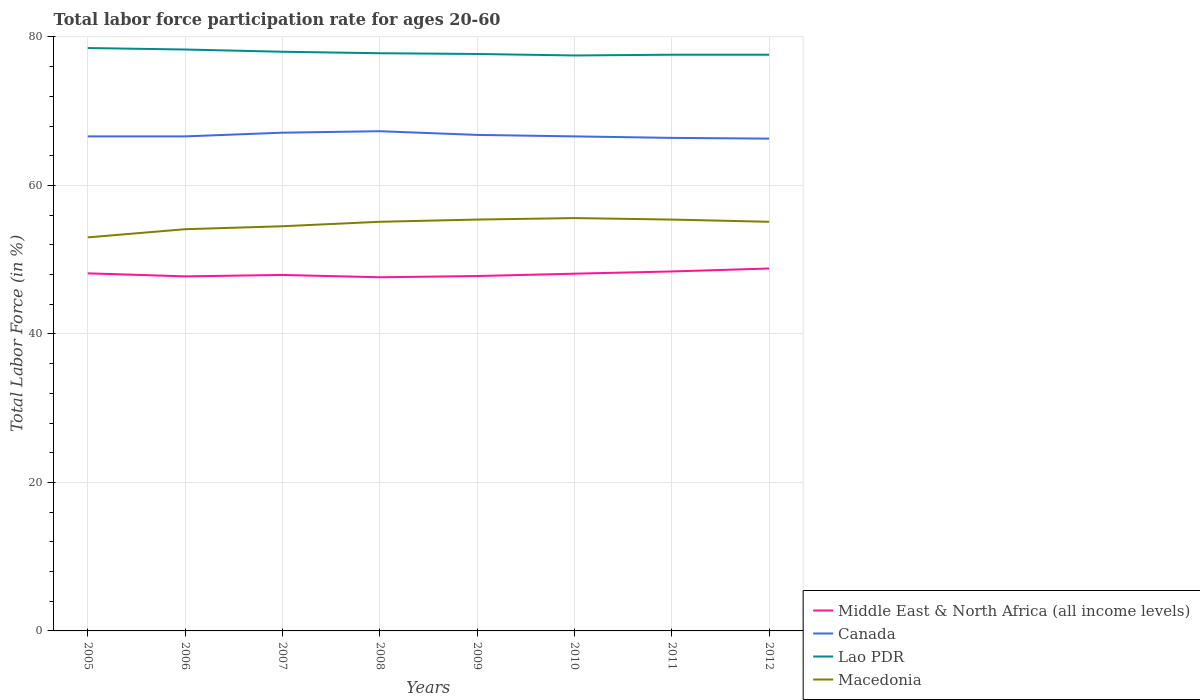Across all years, what is the maximum labor force participation rate in Middle East & North Africa (all income levels)?
Provide a short and direct response. 47.63. In which year was the labor force participation rate in Macedonia maximum?
Offer a terse response. 2005. What is the total labor force participation rate in Macedonia in the graph?
Offer a very short reply. -0.3. What is the difference between the highest and the second highest labor force participation rate in Middle East & North Africa (all income levels)?
Provide a short and direct response. 1.18. What is the difference between the highest and the lowest labor force participation rate in Macedonia?
Provide a short and direct response. 5. Where does the legend appear in the graph?
Keep it short and to the point. Bottom right. How many legend labels are there?
Your answer should be compact. 4. What is the title of the graph?
Your answer should be very brief. Total labor force participation rate for ages 20-60. What is the label or title of the X-axis?
Provide a short and direct response. Years. What is the label or title of the Y-axis?
Provide a succinct answer. Total Labor Force (in %). What is the Total Labor Force (in %) in Middle East & North Africa (all income levels) in 2005?
Keep it short and to the point. 48.16. What is the Total Labor Force (in %) in Canada in 2005?
Offer a terse response. 66.6. What is the Total Labor Force (in %) in Lao PDR in 2005?
Keep it short and to the point. 78.5. What is the Total Labor Force (in %) of Middle East & North Africa (all income levels) in 2006?
Offer a very short reply. 47.75. What is the Total Labor Force (in %) of Canada in 2006?
Provide a short and direct response. 66.6. What is the Total Labor Force (in %) of Lao PDR in 2006?
Provide a short and direct response. 78.3. What is the Total Labor Force (in %) of Macedonia in 2006?
Make the answer very short. 54.1. What is the Total Labor Force (in %) of Middle East & North Africa (all income levels) in 2007?
Provide a succinct answer. 47.94. What is the Total Labor Force (in %) in Canada in 2007?
Make the answer very short. 67.1. What is the Total Labor Force (in %) of Lao PDR in 2007?
Make the answer very short. 78. What is the Total Labor Force (in %) in Macedonia in 2007?
Give a very brief answer. 54.5. What is the Total Labor Force (in %) in Middle East & North Africa (all income levels) in 2008?
Provide a short and direct response. 47.63. What is the Total Labor Force (in %) of Canada in 2008?
Provide a short and direct response. 67.3. What is the Total Labor Force (in %) of Lao PDR in 2008?
Your answer should be very brief. 77.8. What is the Total Labor Force (in %) of Macedonia in 2008?
Give a very brief answer. 55.1. What is the Total Labor Force (in %) in Middle East & North Africa (all income levels) in 2009?
Your response must be concise. 47.79. What is the Total Labor Force (in %) of Canada in 2009?
Offer a very short reply. 66.8. What is the Total Labor Force (in %) in Lao PDR in 2009?
Ensure brevity in your answer.  77.7. What is the Total Labor Force (in %) of Macedonia in 2009?
Your answer should be very brief. 55.4. What is the Total Labor Force (in %) of Middle East & North Africa (all income levels) in 2010?
Offer a very short reply. 48.11. What is the Total Labor Force (in %) of Canada in 2010?
Give a very brief answer. 66.6. What is the Total Labor Force (in %) of Lao PDR in 2010?
Offer a terse response. 77.5. What is the Total Labor Force (in %) in Macedonia in 2010?
Your answer should be very brief. 55.6. What is the Total Labor Force (in %) in Middle East & North Africa (all income levels) in 2011?
Give a very brief answer. 48.41. What is the Total Labor Force (in %) in Canada in 2011?
Ensure brevity in your answer.  66.4. What is the Total Labor Force (in %) of Lao PDR in 2011?
Ensure brevity in your answer.  77.6. What is the Total Labor Force (in %) of Macedonia in 2011?
Offer a very short reply. 55.4. What is the Total Labor Force (in %) in Middle East & North Africa (all income levels) in 2012?
Give a very brief answer. 48.81. What is the Total Labor Force (in %) in Canada in 2012?
Your response must be concise. 66.3. What is the Total Labor Force (in %) in Lao PDR in 2012?
Provide a short and direct response. 77.6. What is the Total Labor Force (in %) in Macedonia in 2012?
Offer a very short reply. 55.1. Across all years, what is the maximum Total Labor Force (in %) of Middle East & North Africa (all income levels)?
Provide a succinct answer. 48.81. Across all years, what is the maximum Total Labor Force (in %) in Canada?
Offer a terse response. 67.3. Across all years, what is the maximum Total Labor Force (in %) in Lao PDR?
Make the answer very short. 78.5. Across all years, what is the maximum Total Labor Force (in %) in Macedonia?
Offer a terse response. 55.6. Across all years, what is the minimum Total Labor Force (in %) in Middle East & North Africa (all income levels)?
Ensure brevity in your answer.  47.63. Across all years, what is the minimum Total Labor Force (in %) in Canada?
Your answer should be compact. 66.3. Across all years, what is the minimum Total Labor Force (in %) in Lao PDR?
Your response must be concise. 77.5. Across all years, what is the minimum Total Labor Force (in %) in Macedonia?
Offer a terse response. 53. What is the total Total Labor Force (in %) in Middle East & North Africa (all income levels) in the graph?
Your response must be concise. 384.6. What is the total Total Labor Force (in %) of Canada in the graph?
Give a very brief answer. 533.7. What is the total Total Labor Force (in %) of Lao PDR in the graph?
Offer a terse response. 623. What is the total Total Labor Force (in %) of Macedonia in the graph?
Your answer should be very brief. 438.2. What is the difference between the Total Labor Force (in %) of Middle East & North Africa (all income levels) in 2005 and that in 2006?
Your answer should be compact. 0.41. What is the difference between the Total Labor Force (in %) of Middle East & North Africa (all income levels) in 2005 and that in 2007?
Make the answer very short. 0.22. What is the difference between the Total Labor Force (in %) of Middle East & North Africa (all income levels) in 2005 and that in 2008?
Your answer should be compact. 0.53. What is the difference between the Total Labor Force (in %) in Canada in 2005 and that in 2008?
Provide a short and direct response. -0.7. What is the difference between the Total Labor Force (in %) of Macedonia in 2005 and that in 2008?
Offer a very short reply. -2.1. What is the difference between the Total Labor Force (in %) in Middle East & North Africa (all income levels) in 2005 and that in 2009?
Your response must be concise. 0.36. What is the difference between the Total Labor Force (in %) in Macedonia in 2005 and that in 2009?
Offer a terse response. -2.4. What is the difference between the Total Labor Force (in %) in Middle East & North Africa (all income levels) in 2005 and that in 2010?
Your answer should be compact. 0.05. What is the difference between the Total Labor Force (in %) of Canada in 2005 and that in 2010?
Your answer should be very brief. 0. What is the difference between the Total Labor Force (in %) in Macedonia in 2005 and that in 2010?
Offer a terse response. -2.6. What is the difference between the Total Labor Force (in %) of Middle East & North Africa (all income levels) in 2005 and that in 2011?
Keep it short and to the point. -0.25. What is the difference between the Total Labor Force (in %) of Canada in 2005 and that in 2011?
Provide a short and direct response. 0.2. What is the difference between the Total Labor Force (in %) in Macedonia in 2005 and that in 2011?
Your answer should be compact. -2.4. What is the difference between the Total Labor Force (in %) of Middle East & North Africa (all income levels) in 2005 and that in 2012?
Make the answer very short. -0.65. What is the difference between the Total Labor Force (in %) in Canada in 2005 and that in 2012?
Make the answer very short. 0.3. What is the difference between the Total Labor Force (in %) in Macedonia in 2005 and that in 2012?
Provide a succinct answer. -2.1. What is the difference between the Total Labor Force (in %) in Middle East & North Africa (all income levels) in 2006 and that in 2007?
Make the answer very short. -0.19. What is the difference between the Total Labor Force (in %) in Lao PDR in 2006 and that in 2007?
Your response must be concise. 0.3. What is the difference between the Total Labor Force (in %) in Macedonia in 2006 and that in 2007?
Provide a short and direct response. -0.4. What is the difference between the Total Labor Force (in %) of Middle East & North Africa (all income levels) in 2006 and that in 2008?
Ensure brevity in your answer.  0.12. What is the difference between the Total Labor Force (in %) of Middle East & North Africa (all income levels) in 2006 and that in 2009?
Keep it short and to the point. -0.04. What is the difference between the Total Labor Force (in %) in Middle East & North Africa (all income levels) in 2006 and that in 2010?
Your response must be concise. -0.36. What is the difference between the Total Labor Force (in %) in Middle East & North Africa (all income levels) in 2006 and that in 2011?
Offer a terse response. -0.66. What is the difference between the Total Labor Force (in %) in Middle East & North Africa (all income levels) in 2006 and that in 2012?
Offer a very short reply. -1.06. What is the difference between the Total Labor Force (in %) of Middle East & North Africa (all income levels) in 2007 and that in 2008?
Ensure brevity in your answer.  0.31. What is the difference between the Total Labor Force (in %) of Lao PDR in 2007 and that in 2008?
Give a very brief answer. 0.2. What is the difference between the Total Labor Force (in %) of Middle East & North Africa (all income levels) in 2007 and that in 2009?
Your answer should be very brief. 0.15. What is the difference between the Total Labor Force (in %) in Canada in 2007 and that in 2009?
Your answer should be compact. 0.3. What is the difference between the Total Labor Force (in %) of Lao PDR in 2007 and that in 2009?
Give a very brief answer. 0.3. What is the difference between the Total Labor Force (in %) of Macedonia in 2007 and that in 2009?
Your response must be concise. -0.9. What is the difference between the Total Labor Force (in %) of Middle East & North Africa (all income levels) in 2007 and that in 2010?
Your response must be concise. -0.17. What is the difference between the Total Labor Force (in %) of Lao PDR in 2007 and that in 2010?
Provide a succinct answer. 0.5. What is the difference between the Total Labor Force (in %) of Middle East & North Africa (all income levels) in 2007 and that in 2011?
Make the answer very short. -0.47. What is the difference between the Total Labor Force (in %) of Canada in 2007 and that in 2011?
Give a very brief answer. 0.7. What is the difference between the Total Labor Force (in %) of Lao PDR in 2007 and that in 2011?
Your answer should be compact. 0.4. What is the difference between the Total Labor Force (in %) of Middle East & North Africa (all income levels) in 2007 and that in 2012?
Provide a succinct answer. -0.87. What is the difference between the Total Labor Force (in %) of Macedonia in 2007 and that in 2012?
Offer a very short reply. -0.6. What is the difference between the Total Labor Force (in %) in Middle East & North Africa (all income levels) in 2008 and that in 2009?
Offer a terse response. -0.16. What is the difference between the Total Labor Force (in %) in Lao PDR in 2008 and that in 2009?
Your answer should be very brief. 0.1. What is the difference between the Total Labor Force (in %) of Middle East & North Africa (all income levels) in 2008 and that in 2010?
Offer a very short reply. -0.48. What is the difference between the Total Labor Force (in %) of Canada in 2008 and that in 2010?
Provide a succinct answer. 0.7. What is the difference between the Total Labor Force (in %) of Macedonia in 2008 and that in 2010?
Your response must be concise. -0.5. What is the difference between the Total Labor Force (in %) of Middle East & North Africa (all income levels) in 2008 and that in 2011?
Offer a terse response. -0.78. What is the difference between the Total Labor Force (in %) of Canada in 2008 and that in 2011?
Offer a very short reply. 0.9. What is the difference between the Total Labor Force (in %) of Middle East & North Africa (all income levels) in 2008 and that in 2012?
Ensure brevity in your answer.  -1.18. What is the difference between the Total Labor Force (in %) of Canada in 2008 and that in 2012?
Make the answer very short. 1. What is the difference between the Total Labor Force (in %) in Middle East & North Africa (all income levels) in 2009 and that in 2010?
Your response must be concise. -0.32. What is the difference between the Total Labor Force (in %) in Canada in 2009 and that in 2010?
Your answer should be compact. 0.2. What is the difference between the Total Labor Force (in %) in Lao PDR in 2009 and that in 2010?
Make the answer very short. 0.2. What is the difference between the Total Labor Force (in %) in Macedonia in 2009 and that in 2010?
Give a very brief answer. -0.2. What is the difference between the Total Labor Force (in %) in Middle East & North Africa (all income levels) in 2009 and that in 2011?
Make the answer very short. -0.62. What is the difference between the Total Labor Force (in %) of Lao PDR in 2009 and that in 2011?
Your answer should be compact. 0.1. What is the difference between the Total Labor Force (in %) in Middle East & North Africa (all income levels) in 2009 and that in 2012?
Keep it short and to the point. -1.02. What is the difference between the Total Labor Force (in %) in Canada in 2009 and that in 2012?
Make the answer very short. 0.5. What is the difference between the Total Labor Force (in %) of Lao PDR in 2009 and that in 2012?
Your answer should be compact. 0.1. What is the difference between the Total Labor Force (in %) in Macedonia in 2009 and that in 2012?
Give a very brief answer. 0.3. What is the difference between the Total Labor Force (in %) in Middle East & North Africa (all income levels) in 2010 and that in 2011?
Provide a succinct answer. -0.3. What is the difference between the Total Labor Force (in %) of Canada in 2010 and that in 2011?
Your response must be concise. 0.2. What is the difference between the Total Labor Force (in %) in Middle East & North Africa (all income levels) in 2010 and that in 2012?
Your answer should be very brief. -0.7. What is the difference between the Total Labor Force (in %) in Lao PDR in 2010 and that in 2012?
Provide a succinct answer. -0.1. What is the difference between the Total Labor Force (in %) of Middle East & North Africa (all income levels) in 2011 and that in 2012?
Your response must be concise. -0.4. What is the difference between the Total Labor Force (in %) in Macedonia in 2011 and that in 2012?
Your response must be concise. 0.3. What is the difference between the Total Labor Force (in %) in Middle East & North Africa (all income levels) in 2005 and the Total Labor Force (in %) in Canada in 2006?
Your response must be concise. -18.44. What is the difference between the Total Labor Force (in %) of Middle East & North Africa (all income levels) in 2005 and the Total Labor Force (in %) of Lao PDR in 2006?
Provide a short and direct response. -30.14. What is the difference between the Total Labor Force (in %) in Middle East & North Africa (all income levels) in 2005 and the Total Labor Force (in %) in Macedonia in 2006?
Make the answer very short. -5.94. What is the difference between the Total Labor Force (in %) in Canada in 2005 and the Total Labor Force (in %) in Lao PDR in 2006?
Make the answer very short. -11.7. What is the difference between the Total Labor Force (in %) of Lao PDR in 2005 and the Total Labor Force (in %) of Macedonia in 2006?
Provide a succinct answer. 24.4. What is the difference between the Total Labor Force (in %) in Middle East & North Africa (all income levels) in 2005 and the Total Labor Force (in %) in Canada in 2007?
Make the answer very short. -18.94. What is the difference between the Total Labor Force (in %) in Middle East & North Africa (all income levels) in 2005 and the Total Labor Force (in %) in Lao PDR in 2007?
Offer a very short reply. -29.84. What is the difference between the Total Labor Force (in %) in Middle East & North Africa (all income levels) in 2005 and the Total Labor Force (in %) in Macedonia in 2007?
Provide a short and direct response. -6.34. What is the difference between the Total Labor Force (in %) of Canada in 2005 and the Total Labor Force (in %) of Lao PDR in 2007?
Keep it short and to the point. -11.4. What is the difference between the Total Labor Force (in %) of Lao PDR in 2005 and the Total Labor Force (in %) of Macedonia in 2007?
Provide a succinct answer. 24. What is the difference between the Total Labor Force (in %) in Middle East & North Africa (all income levels) in 2005 and the Total Labor Force (in %) in Canada in 2008?
Your response must be concise. -19.14. What is the difference between the Total Labor Force (in %) of Middle East & North Africa (all income levels) in 2005 and the Total Labor Force (in %) of Lao PDR in 2008?
Your answer should be very brief. -29.64. What is the difference between the Total Labor Force (in %) in Middle East & North Africa (all income levels) in 2005 and the Total Labor Force (in %) in Macedonia in 2008?
Ensure brevity in your answer.  -6.94. What is the difference between the Total Labor Force (in %) of Lao PDR in 2005 and the Total Labor Force (in %) of Macedonia in 2008?
Keep it short and to the point. 23.4. What is the difference between the Total Labor Force (in %) of Middle East & North Africa (all income levels) in 2005 and the Total Labor Force (in %) of Canada in 2009?
Give a very brief answer. -18.64. What is the difference between the Total Labor Force (in %) of Middle East & North Africa (all income levels) in 2005 and the Total Labor Force (in %) of Lao PDR in 2009?
Provide a succinct answer. -29.54. What is the difference between the Total Labor Force (in %) of Middle East & North Africa (all income levels) in 2005 and the Total Labor Force (in %) of Macedonia in 2009?
Offer a very short reply. -7.24. What is the difference between the Total Labor Force (in %) in Canada in 2005 and the Total Labor Force (in %) in Lao PDR in 2009?
Your response must be concise. -11.1. What is the difference between the Total Labor Force (in %) in Canada in 2005 and the Total Labor Force (in %) in Macedonia in 2009?
Your answer should be compact. 11.2. What is the difference between the Total Labor Force (in %) of Lao PDR in 2005 and the Total Labor Force (in %) of Macedonia in 2009?
Your answer should be very brief. 23.1. What is the difference between the Total Labor Force (in %) of Middle East & North Africa (all income levels) in 2005 and the Total Labor Force (in %) of Canada in 2010?
Make the answer very short. -18.44. What is the difference between the Total Labor Force (in %) in Middle East & North Africa (all income levels) in 2005 and the Total Labor Force (in %) in Lao PDR in 2010?
Provide a short and direct response. -29.34. What is the difference between the Total Labor Force (in %) in Middle East & North Africa (all income levels) in 2005 and the Total Labor Force (in %) in Macedonia in 2010?
Ensure brevity in your answer.  -7.44. What is the difference between the Total Labor Force (in %) in Lao PDR in 2005 and the Total Labor Force (in %) in Macedonia in 2010?
Give a very brief answer. 22.9. What is the difference between the Total Labor Force (in %) in Middle East & North Africa (all income levels) in 2005 and the Total Labor Force (in %) in Canada in 2011?
Keep it short and to the point. -18.24. What is the difference between the Total Labor Force (in %) of Middle East & North Africa (all income levels) in 2005 and the Total Labor Force (in %) of Lao PDR in 2011?
Give a very brief answer. -29.44. What is the difference between the Total Labor Force (in %) in Middle East & North Africa (all income levels) in 2005 and the Total Labor Force (in %) in Macedonia in 2011?
Offer a very short reply. -7.24. What is the difference between the Total Labor Force (in %) of Canada in 2005 and the Total Labor Force (in %) of Lao PDR in 2011?
Provide a short and direct response. -11. What is the difference between the Total Labor Force (in %) in Lao PDR in 2005 and the Total Labor Force (in %) in Macedonia in 2011?
Keep it short and to the point. 23.1. What is the difference between the Total Labor Force (in %) of Middle East & North Africa (all income levels) in 2005 and the Total Labor Force (in %) of Canada in 2012?
Offer a terse response. -18.14. What is the difference between the Total Labor Force (in %) of Middle East & North Africa (all income levels) in 2005 and the Total Labor Force (in %) of Lao PDR in 2012?
Offer a very short reply. -29.44. What is the difference between the Total Labor Force (in %) of Middle East & North Africa (all income levels) in 2005 and the Total Labor Force (in %) of Macedonia in 2012?
Provide a succinct answer. -6.94. What is the difference between the Total Labor Force (in %) in Canada in 2005 and the Total Labor Force (in %) in Lao PDR in 2012?
Offer a very short reply. -11. What is the difference between the Total Labor Force (in %) in Lao PDR in 2005 and the Total Labor Force (in %) in Macedonia in 2012?
Your response must be concise. 23.4. What is the difference between the Total Labor Force (in %) of Middle East & North Africa (all income levels) in 2006 and the Total Labor Force (in %) of Canada in 2007?
Your response must be concise. -19.35. What is the difference between the Total Labor Force (in %) in Middle East & North Africa (all income levels) in 2006 and the Total Labor Force (in %) in Lao PDR in 2007?
Offer a very short reply. -30.25. What is the difference between the Total Labor Force (in %) of Middle East & North Africa (all income levels) in 2006 and the Total Labor Force (in %) of Macedonia in 2007?
Your answer should be compact. -6.75. What is the difference between the Total Labor Force (in %) of Canada in 2006 and the Total Labor Force (in %) of Lao PDR in 2007?
Make the answer very short. -11.4. What is the difference between the Total Labor Force (in %) of Lao PDR in 2006 and the Total Labor Force (in %) of Macedonia in 2007?
Give a very brief answer. 23.8. What is the difference between the Total Labor Force (in %) in Middle East & North Africa (all income levels) in 2006 and the Total Labor Force (in %) in Canada in 2008?
Give a very brief answer. -19.55. What is the difference between the Total Labor Force (in %) in Middle East & North Africa (all income levels) in 2006 and the Total Labor Force (in %) in Lao PDR in 2008?
Offer a very short reply. -30.05. What is the difference between the Total Labor Force (in %) in Middle East & North Africa (all income levels) in 2006 and the Total Labor Force (in %) in Macedonia in 2008?
Ensure brevity in your answer.  -7.35. What is the difference between the Total Labor Force (in %) in Canada in 2006 and the Total Labor Force (in %) in Lao PDR in 2008?
Provide a succinct answer. -11.2. What is the difference between the Total Labor Force (in %) of Canada in 2006 and the Total Labor Force (in %) of Macedonia in 2008?
Your answer should be very brief. 11.5. What is the difference between the Total Labor Force (in %) of Lao PDR in 2006 and the Total Labor Force (in %) of Macedonia in 2008?
Provide a succinct answer. 23.2. What is the difference between the Total Labor Force (in %) in Middle East & North Africa (all income levels) in 2006 and the Total Labor Force (in %) in Canada in 2009?
Give a very brief answer. -19.05. What is the difference between the Total Labor Force (in %) in Middle East & North Africa (all income levels) in 2006 and the Total Labor Force (in %) in Lao PDR in 2009?
Provide a succinct answer. -29.95. What is the difference between the Total Labor Force (in %) of Middle East & North Africa (all income levels) in 2006 and the Total Labor Force (in %) of Macedonia in 2009?
Make the answer very short. -7.65. What is the difference between the Total Labor Force (in %) in Canada in 2006 and the Total Labor Force (in %) in Macedonia in 2009?
Offer a very short reply. 11.2. What is the difference between the Total Labor Force (in %) of Lao PDR in 2006 and the Total Labor Force (in %) of Macedonia in 2009?
Make the answer very short. 22.9. What is the difference between the Total Labor Force (in %) in Middle East & North Africa (all income levels) in 2006 and the Total Labor Force (in %) in Canada in 2010?
Keep it short and to the point. -18.85. What is the difference between the Total Labor Force (in %) of Middle East & North Africa (all income levels) in 2006 and the Total Labor Force (in %) of Lao PDR in 2010?
Provide a succinct answer. -29.75. What is the difference between the Total Labor Force (in %) in Middle East & North Africa (all income levels) in 2006 and the Total Labor Force (in %) in Macedonia in 2010?
Make the answer very short. -7.85. What is the difference between the Total Labor Force (in %) in Lao PDR in 2006 and the Total Labor Force (in %) in Macedonia in 2010?
Offer a terse response. 22.7. What is the difference between the Total Labor Force (in %) of Middle East & North Africa (all income levels) in 2006 and the Total Labor Force (in %) of Canada in 2011?
Give a very brief answer. -18.65. What is the difference between the Total Labor Force (in %) in Middle East & North Africa (all income levels) in 2006 and the Total Labor Force (in %) in Lao PDR in 2011?
Your response must be concise. -29.85. What is the difference between the Total Labor Force (in %) of Middle East & North Africa (all income levels) in 2006 and the Total Labor Force (in %) of Macedonia in 2011?
Ensure brevity in your answer.  -7.65. What is the difference between the Total Labor Force (in %) of Canada in 2006 and the Total Labor Force (in %) of Lao PDR in 2011?
Provide a succinct answer. -11. What is the difference between the Total Labor Force (in %) of Lao PDR in 2006 and the Total Labor Force (in %) of Macedonia in 2011?
Give a very brief answer. 22.9. What is the difference between the Total Labor Force (in %) in Middle East & North Africa (all income levels) in 2006 and the Total Labor Force (in %) in Canada in 2012?
Give a very brief answer. -18.55. What is the difference between the Total Labor Force (in %) of Middle East & North Africa (all income levels) in 2006 and the Total Labor Force (in %) of Lao PDR in 2012?
Your response must be concise. -29.85. What is the difference between the Total Labor Force (in %) of Middle East & North Africa (all income levels) in 2006 and the Total Labor Force (in %) of Macedonia in 2012?
Provide a short and direct response. -7.35. What is the difference between the Total Labor Force (in %) in Canada in 2006 and the Total Labor Force (in %) in Lao PDR in 2012?
Offer a very short reply. -11. What is the difference between the Total Labor Force (in %) in Lao PDR in 2006 and the Total Labor Force (in %) in Macedonia in 2012?
Offer a terse response. 23.2. What is the difference between the Total Labor Force (in %) in Middle East & North Africa (all income levels) in 2007 and the Total Labor Force (in %) in Canada in 2008?
Your answer should be compact. -19.36. What is the difference between the Total Labor Force (in %) in Middle East & North Africa (all income levels) in 2007 and the Total Labor Force (in %) in Lao PDR in 2008?
Offer a very short reply. -29.86. What is the difference between the Total Labor Force (in %) of Middle East & North Africa (all income levels) in 2007 and the Total Labor Force (in %) of Macedonia in 2008?
Ensure brevity in your answer.  -7.16. What is the difference between the Total Labor Force (in %) of Canada in 2007 and the Total Labor Force (in %) of Macedonia in 2008?
Ensure brevity in your answer.  12. What is the difference between the Total Labor Force (in %) in Lao PDR in 2007 and the Total Labor Force (in %) in Macedonia in 2008?
Keep it short and to the point. 22.9. What is the difference between the Total Labor Force (in %) of Middle East & North Africa (all income levels) in 2007 and the Total Labor Force (in %) of Canada in 2009?
Make the answer very short. -18.86. What is the difference between the Total Labor Force (in %) in Middle East & North Africa (all income levels) in 2007 and the Total Labor Force (in %) in Lao PDR in 2009?
Offer a terse response. -29.76. What is the difference between the Total Labor Force (in %) of Middle East & North Africa (all income levels) in 2007 and the Total Labor Force (in %) of Macedonia in 2009?
Your response must be concise. -7.46. What is the difference between the Total Labor Force (in %) of Canada in 2007 and the Total Labor Force (in %) of Macedonia in 2009?
Give a very brief answer. 11.7. What is the difference between the Total Labor Force (in %) in Lao PDR in 2007 and the Total Labor Force (in %) in Macedonia in 2009?
Give a very brief answer. 22.6. What is the difference between the Total Labor Force (in %) in Middle East & North Africa (all income levels) in 2007 and the Total Labor Force (in %) in Canada in 2010?
Your answer should be compact. -18.66. What is the difference between the Total Labor Force (in %) of Middle East & North Africa (all income levels) in 2007 and the Total Labor Force (in %) of Lao PDR in 2010?
Your answer should be compact. -29.56. What is the difference between the Total Labor Force (in %) in Middle East & North Africa (all income levels) in 2007 and the Total Labor Force (in %) in Macedonia in 2010?
Your answer should be compact. -7.66. What is the difference between the Total Labor Force (in %) of Canada in 2007 and the Total Labor Force (in %) of Lao PDR in 2010?
Make the answer very short. -10.4. What is the difference between the Total Labor Force (in %) of Lao PDR in 2007 and the Total Labor Force (in %) of Macedonia in 2010?
Your answer should be very brief. 22.4. What is the difference between the Total Labor Force (in %) in Middle East & North Africa (all income levels) in 2007 and the Total Labor Force (in %) in Canada in 2011?
Provide a succinct answer. -18.46. What is the difference between the Total Labor Force (in %) of Middle East & North Africa (all income levels) in 2007 and the Total Labor Force (in %) of Lao PDR in 2011?
Your response must be concise. -29.66. What is the difference between the Total Labor Force (in %) in Middle East & North Africa (all income levels) in 2007 and the Total Labor Force (in %) in Macedonia in 2011?
Provide a short and direct response. -7.46. What is the difference between the Total Labor Force (in %) of Canada in 2007 and the Total Labor Force (in %) of Lao PDR in 2011?
Your answer should be compact. -10.5. What is the difference between the Total Labor Force (in %) of Canada in 2007 and the Total Labor Force (in %) of Macedonia in 2011?
Offer a very short reply. 11.7. What is the difference between the Total Labor Force (in %) of Lao PDR in 2007 and the Total Labor Force (in %) of Macedonia in 2011?
Keep it short and to the point. 22.6. What is the difference between the Total Labor Force (in %) of Middle East & North Africa (all income levels) in 2007 and the Total Labor Force (in %) of Canada in 2012?
Provide a succinct answer. -18.36. What is the difference between the Total Labor Force (in %) of Middle East & North Africa (all income levels) in 2007 and the Total Labor Force (in %) of Lao PDR in 2012?
Offer a very short reply. -29.66. What is the difference between the Total Labor Force (in %) of Middle East & North Africa (all income levels) in 2007 and the Total Labor Force (in %) of Macedonia in 2012?
Your answer should be compact. -7.16. What is the difference between the Total Labor Force (in %) in Lao PDR in 2007 and the Total Labor Force (in %) in Macedonia in 2012?
Make the answer very short. 22.9. What is the difference between the Total Labor Force (in %) of Middle East & North Africa (all income levels) in 2008 and the Total Labor Force (in %) of Canada in 2009?
Offer a terse response. -19.17. What is the difference between the Total Labor Force (in %) of Middle East & North Africa (all income levels) in 2008 and the Total Labor Force (in %) of Lao PDR in 2009?
Offer a terse response. -30.07. What is the difference between the Total Labor Force (in %) of Middle East & North Africa (all income levels) in 2008 and the Total Labor Force (in %) of Macedonia in 2009?
Ensure brevity in your answer.  -7.77. What is the difference between the Total Labor Force (in %) of Lao PDR in 2008 and the Total Labor Force (in %) of Macedonia in 2009?
Make the answer very short. 22.4. What is the difference between the Total Labor Force (in %) in Middle East & North Africa (all income levels) in 2008 and the Total Labor Force (in %) in Canada in 2010?
Your response must be concise. -18.97. What is the difference between the Total Labor Force (in %) in Middle East & North Africa (all income levels) in 2008 and the Total Labor Force (in %) in Lao PDR in 2010?
Your answer should be very brief. -29.87. What is the difference between the Total Labor Force (in %) in Middle East & North Africa (all income levels) in 2008 and the Total Labor Force (in %) in Macedonia in 2010?
Provide a succinct answer. -7.97. What is the difference between the Total Labor Force (in %) of Canada in 2008 and the Total Labor Force (in %) of Lao PDR in 2010?
Keep it short and to the point. -10.2. What is the difference between the Total Labor Force (in %) of Middle East & North Africa (all income levels) in 2008 and the Total Labor Force (in %) of Canada in 2011?
Your answer should be very brief. -18.77. What is the difference between the Total Labor Force (in %) in Middle East & North Africa (all income levels) in 2008 and the Total Labor Force (in %) in Lao PDR in 2011?
Offer a very short reply. -29.97. What is the difference between the Total Labor Force (in %) of Middle East & North Africa (all income levels) in 2008 and the Total Labor Force (in %) of Macedonia in 2011?
Offer a very short reply. -7.77. What is the difference between the Total Labor Force (in %) in Canada in 2008 and the Total Labor Force (in %) in Lao PDR in 2011?
Offer a terse response. -10.3. What is the difference between the Total Labor Force (in %) of Canada in 2008 and the Total Labor Force (in %) of Macedonia in 2011?
Provide a short and direct response. 11.9. What is the difference between the Total Labor Force (in %) in Lao PDR in 2008 and the Total Labor Force (in %) in Macedonia in 2011?
Provide a succinct answer. 22.4. What is the difference between the Total Labor Force (in %) in Middle East & North Africa (all income levels) in 2008 and the Total Labor Force (in %) in Canada in 2012?
Your answer should be compact. -18.67. What is the difference between the Total Labor Force (in %) of Middle East & North Africa (all income levels) in 2008 and the Total Labor Force (in %) of Lao PDR in 2012?
Your answer should be compact. -29.97. What is the difference between the Total Labor Force (in %) of Middle East & North Africa (all income levels) in 2008 and the Total Labor Force (in %) of Macedonia in 2012?
Give a very brief answer. -7.47. What is the difference between the Total Labor Force (in %) in Canada in 2008 and the Total Labor Force (in %) in Lao PDR in 2012?
Make the answer very short. -10.3. What is the difference between the Total Labor Force (in %) in Canada in 2008 and the Total Labor Force (in %) in Macedonia in 2012?
Make the answer very short. 12.2. What is the difference between the Total Labor Force (in %) of Lao PDR in 2008 and the Total Labor Force (in %) of Macedonia in 2012?
Ensure brevity in your answer.  22.7. What is the difference between the Total Labor Force (in %) in Middle East & North Africa (all income levels) in 2009 and the Total Labor Force (in %) in Canada in 2010?
Provide a short and direct response. -18.81. What is the difference between the Total Labor Force (in %) of Middle East & North Africa (all income levels) in 2009 and the Total Labor Force (in %) of Lao PDR in 2010?
Make the answer very short. -29.71. What is the difference between the Total Labor Force (in %) in Middle East & North Africa (all income levels) in 2009 and the Total Labor Force (in %) in Macedonia in 2010?
Ensure brevity in your answer.  -7.81. What is the difference between the Total Labor Force (in %) of Canada in 2009 and the Total Labor Force (in %) of Lao PDR in 2010?
Give a very brief answer. -10.7. What is the difference between the Total Labor Force (in %) of Lao PDR in 2009 and the Total Labor Force (in %) of Macedonia in 2010?
Your response must be concise. 22.1. What is the difference between the Total Labor Force (in %) of Middle East & North Africa (all income levels) in 2009 and the Total Labor Force (in %) of Canada in 2011?
Provide a succinct answer. -18.61. What is the difference between the Total Labor Force (in %) in Middle East & North Africa (all income levels) in 2009 and the Total Labor Force (in %) in Lao PDR in 2011?
Provide a short and direct response. -29.81. What is the difference between the Total Labor Force (in %) in Middle East & North Africa (all income levels) in 2009 and the Total Labor Force (in %) in Macedonia in 2011?
Make the answer very short. -7.61. What is the difference between the Total Labor Force (in %) of Canada in 2009 and the Total Labor Force (in %) of Macedonia in 2011?
Offer a terse response. 11.4. What is the difference between the Total Labor Force (in %) of Lao PDR in 2009 and the Total Labor Force (in %) of Macedonia in 2011?
Offer a terse response. 22.3. What is the difference between the Total Labor Force (in %) in Middle East & North Africa (all income levels) in 2009 and the Total Labor Force (in %) in Canada in 2012?
Your answer should be very brief. -18.51. What is the difference between the Total Labor Force (in %) in Middle East & North Africa (all income levels) in 2009 and the Total Labor Force (in %) in Lao PDR in 2012?
Give a very brief answer. -29.81. What is the difference between the Total Labor Force (in %) in Middle East & North Africa (all income levels) in 2009 and the Total Labor Force (in %) in Macedonia in 2012?
Offer a very short reply. -7.31. What is the difference between the Total Labor Force (in %) of Canada in 2009 and the Total Labor Force (in %) of Macedonia in 2012?
Offer a very short reply. 11.7. What is the difference between the Total Labor Force (in %) in Lao PDR in 2009 and the Total Labor Force (in %) in Macedonia in 2012?
Give a very brief answer. 22.6. What is the difference between the Total Labor Force (in %) of Middle East & North Africa (all income levels) in 2010 and the Total Labor Force (in %) of Canada in 2011?
Keep it short and to the point. -18.29. What is the difference between the Total Labor Force (in %) in Middle East & North Africa (all income levels) in 2010 and the Total Labor Force (in %) in Lao PDR in 2011?
Give a very brief answer. -29.49. What is the difference between the Total Labor Force (in %) of Middle East & North Africa (all income levels) in 2010 and the Total Labor Force (in %) of Macedonia in 2011?
Your response must be concise. -7.29. What is the difference between the Total Labor Force (in %) in Lao PDR in 2010 and the Total Labor Force (in %) in Macedonia in 2011?
Your answer should be compact. 22.1. What is the difference between the Total Labor Force (in %) of Middle East & North Africa (all income levels) in 2010 and the Total Labor Force (in %) of Canada in 2012?
Your response must be concise. -18.19. What is the difference between the Total Labor Force (in %) in Middle East & North Africa (all income levels) in 2010 and the Total Labor Force (in %) in Lao PDR in 2012?
Offer a terse response. -29.49. What is the difference between the Total Labor Force (in %) of Middle East & North Africa (all income levels) in 2010 and the Total Labor Force (in %) of Macedonia in 2012?
Ensure brevity in your answer.  -6.99. What is the difference between the Total Labor Force (in %) in Lao PDR in 2010 and the Total Labor Force (in %) in Macedonia in 2012?
Keep it short and to the point. 22.4. What is the difference between the Total Labor Force (in %) in Middle East & North Africa (all income levels) in 2011 and the Total Labor Force (in %) in Canada in 2012?
Ensure brevity in your answer.  -17.89. What is the difference between the Total Labor Force (in %) of Middle East & North Africa (all income levels) in 2011 and the Total Labor Force (in %) of Lao PDR in 2012?
Offer a very short reply. -29.19. What is the difference between the Total Labor Force (in %) of Middle East & North Africa (all income levels) in 2011 and the Total Labor Force (in %) of Macedonia in 2012?
Provide a succinct answer. -6.69. What is the difference between the Total Labor Force (in %) of Lao PDR in 2011 and the Total Labor Force (in %) of Macedonia in 2012?
Provide a short and direct response. 22.5. What is the average Total Labor Force (in %) of Middle East & North Africa (all income levels) per year?
Provide a short and direct response. 48.07. What is the average Total Labor Force (in %) in Canada per year?
Give a very brief answer. 66.71. What is the average Total Labor Force (in %) in Lao PDR per year?
Make the answer very short. 77.88. What is the average Total Labor Force (in %) in Macedonia per year?
Provide a succinct answer. 54.77. In the year 2005, what is the difference between the Total Labor Force (in %) in Middle East & North Africa (all income levels) and Total Labor Force (in %) in Canada?
Give a very brief answer. -18.44. In the year 2005, what is the difference between the Total Labor Force (in %) of Middle East & North Africa (all income levels) and Total Labor Force (in %) of Lao PDR?
Offer a terse response. -30.34. In the year 2005, what is the difference between the Total Labor Force (in %) in Middle East & North Africa (all income levels) and Total Labor Force (in %) in Macedonia?
Offer a very short reply. -4.84. In the year 2005, what is the difference between the Total Labor Force (in %) of Canada and Total Labor Force (in %) of Lao PDR?
Provide a succinct answer. -11.9. In the year 2005, what is the difference between the Total Labor Force (in %) in Canada and Total Labor Force (in %) in Macedonia?
Your response must be concise. 13.6. In the year 2005, what is the difference between the Total Labor Force (in %) in Lao PDR and Total Labor Force (in %) in Macedonia?
Provide a short and direct response. 25.5. In the year 2006, what is the difference between the Total Labor Force (in %) in Middle East & North Africa (all income levels) and Total Labor Force (in %) in Canada?
Keep it short and to the point. -18.85. In the year 2006, what is the difference between the Total Labor Force (in %) of Middle East & North Africa (all income levels) and Total Labor Force (in %) of Lao PDR?
Your answer should be compact. -30.55. In the year 2006, what is the difference between the Total Labor Force (in %) in Middle East & North Africa (all income levels) and Total Labor Force (in %) in Macedonia?
Ensure brevity in your answer.  -6.35. In the year 2006, what is the difference between the Total Labor Force (in %) in Canada and Total Labor Force (in %) in Lao PDR?
Provide a succinct answer. -11.7. In the year 2006, what is the difference between the Total Labor Force (in %) of Canada and Total Labor Force (in %) of Macedonia?
Provide a succinct answer. 12.5. In the year 2006, what is the difference between the Total Labor Force (in %) of Lao PDR and Total Labor Force (in %) of Macedonia?
Give a very brief answer. 24.2. In the year 2007, what is the difference between the Total Labor Force (in %) in Middle East & North Africa (all income levels) and Total Labor Force (in %) in Canada?
Offer a terse response. -19.16. In the year 2007, what is the difference between the Total Labor Force (in %) of Middle East & North Africa (all income levels) and Total Labor Force (in %) of Lao PDR?
Your answer should be compact. -30.06. In the year 2007, what is the difference between the Total Labor Force (in %) of Middle East & North Africa (all income levels) and Total Labor Force (in %) of Macedonia?
Offer a terse response. -6.56. In the year 2007, what is the difference between the Total Labor Force (in %) in Canada and Total Labor Force (in %) in Macedonia?
Your answer should be very brief. 12.6. In the year 2007, what is the difference between the Total Labor Force (in %) in Lao PDR and Total Labor Force (in %) in Macedonia?
Your response must be concise. 23.5. In the year 2008, what is the difference between the Total Labor Force (in %) of Middle East & North Africa (all income levels) and Total Labor Force (in %) of Canada?
Give a very brief answer. -19.67. In the year 2008, what is the difference between the Total Labor Force (in %) of Middle East & North Africa (all income levels) and Total Labor Force (in %) of Lao PDR?
Provide a succinct answer. -30.17. In the year 2008, what is the difference between the Total Labor Force (in %) in Middle East & North Africa (all income levels) and Total Labor Force (in %) in Macedonia?
Provide a short and direct response. -7.47. In the year 2008, what is the difference between the Total Labor Force (in %) in Canada and Total Labor Force (in %) in Lao PDR?
Ensure brevity in your answer.  -10.5. In the year 2008, what is the difference between the Total Labor Force (in %) in Canada and Total Labor Force (in %) in Macedonia?
Ensure brevity in your answer.  12.2. In the year 2008, what is the difference between the Total Labor Force (in %) of Lao PDR and Total Labor Force (in %) of Macedonia?
Your answer should be very brief. 22.7. In the year 2009, what is the difference between the Total Labor Force (in %) in Middle East & North Africa (all income levels) and Total Labor Force (in %) in Canada?
Give a very brief answer. -19.01. In the year 2009, what is the difference between the Total Labor Force (in %) in Middle East & North Africa (all income levels) and Total Labor Force (in %) in Lao PDR?
Ensure brevity in your answer.  -29.91. In the year 2009, what is the difference between the Total Labor Force (in %) in Middle East & North Africa (all income levels) and Total Labor Force (in %) in Macedonia?
Your answer should be compact. -7.61. In the year 2009, what is the difference between the Total Labor Force (in %) in Lao PDR and Total Labor Force (in %) in Macedonia?
Your response must be concise. 22.3. In the year 2010, what is the difference between the Total Labor Force (in %) in Middle East & North Africa (all income levels) and Total Labor Force (in %) in Canada?
Provide a short and direct response. -18.49. In the year 2010, what is the difference between the Total Labor Force (in %) in Middle East & North Africa (all income levels) and Total Labor Force (in %) in Lao PDR?
Provide a short and direct response. -29.39. In the year 2010, what is the difference between the Total Labor Force (in %) of Middle East & North Africa (all income levels) and Total Labor Force (in %) of Macedonia?
Give a very brief answer. -7.49. In the year 2010, what is the difference between the Total Labor Force (in %) in Canada and Total Labor Force (in %) in Lao PDR?
Offer a terse response. -10.9. In the year 2010, what is the difference between the Total Labor Force (in %) of Lao PDR and Total Labor Force (in %) of Macedonia?
Provide a succinct answer. 21.9. In the year 2011, what is the difference between the Total Labor Force (in %) in Middle East & North Africa (all income levels) and Total Labor Force (in %) in Canada?
Your answer should be compact. -17.99. In the year 2011, what is the difference between the Total Labor Force (in %) in Middle East & North Africa (all income levels) and Total Labor Force (in %) in Lao PDR?
Give a very brief answer. -29.19. In the year 2011, what is the difference between the Total Labor Force (in %) of Middle East & North Africa (all income levels) and Total Labor Force (in %) of Macedonia?
Provide a short and direct response. -6.99. In the year 2011, what is the difference between the Total Labor Force (in %) in Lao PDR and Total Labor Force (in %) in Macedonia?
Offer a terse response. 22.2. In the year 2012, what is the difference between the Total Labor Force (in %) in Middle East & North Africa (all income levels) and Total Labor Force (in %) in Canada?
Make the answer very short. -17.49. In the year 2012, what is the difference between the Total Labor Force (in %) in Middle East & North Africa (all income levels) and Total Labor Force (in %) in Lao PDR?
Keep it short and to the point. -28.79. In the year 2012, what is the difference between the Total Labor Force (in %) of Middle East & North Africa (all income levels) and Total Labor Force (in %) of Macedonia?
Make the answer very short. -6.29. In the year 2012, what is the difference between the Total Labor Force (in %) of Canada and Total Labor Force (in %) of Macedonia?
Give a very brief answer. 11.2. What is the ratio of the Total Labor Force (in %) of Middle East & North Africa (all income levels) in 2005 to that in 2006?
Provide a succinct answer. 1.01. What is the ratio of the Total Labor Force (in %) of Lao PDR in 2005 to that in 2006?
Make the answer very short. 1. What is the ratio of the Total Labor Force (in %) of Macedonia in 2005 to that in 2006?
Keep it short and to the point. 0.98. What is the ratio of the Total Labor Force (in %) in Lao PDR in 2005 to that in 2007?
Your answer should be very brief. 1.01. What is the ratio of the Total Labor Force (in %) of Macedonia in 2005 to that in 2007?
Give a very brief answer. 0.97. What is the ratio of the Total Labor Force (in %) of Middle East & North Africa (all income levels) in 2005 to that in 2008?
Make the answer very short. 1.01. What is the ratio of the Total Labor Force (in %) in Lao PDR in 2005 to that in 2008?
Provide a succinct answer. 1.01. What is the ratio of the Total Labor Force (in %) in Macedonia in 2005 to that in 2008?
Keep it short and to the point. 0.96. What is the ratio of the Total Labor Force (in %) of Middle East & North Africa (all income levels) in 2005 to that in 2009?
Make the answer very short. 1.01. What is the ratio of the Total Labor Force (in %) in Lao PDR in 2005 to that in 2009?
Offer a very short reply. 1.01. What is the ratio of the Total Labor Force (in %) in Macedonia in 2005 to that in 2009?
Provide a short and direct response. 0.96. What is the ratio of the Total Labor Force (in %) of Canada in 2005 to that in 2010?
Offer a terse response. 1. What is the ratio of the Total Labor Force (in %) of Lao PDR in 2005 to that in 2010?
Offer a very short reply. 1.01. What is the ratio of the Total Labor Force (in %) in Macedonia in 2005 to that in 2010?
Provide a succinct answer. 0.95. What is the ratio of the Total Labor Force (in %) in Lao PDR in 2005 to that in 2011?
Your answer should be very brief. 1.01. What is the ratio of the Total Labor Force (in %) in Macedonia in 2005 to that in 2011?
Provide a short and direct response. 0.96. What is the ratio of the Total Labor Force (in %) in Middle East & North Africa (all income levels) in 2005 to that in 2012?
Offer a very short reply. 0.99. What is the ratio of the Total Labor Force (in %) of Lao PDR in 2005 to that in 2012?
Provide a short and direct response. 1.01. What is the ratio of the Total Labor Force (in %) in Macedonia in 2005 to that in 2012?
Provide a short and direct response. 0.96. What is the ratio of the Total Labor Force (in %) in Middle East & North Africa (all income levels) in 2006 to that in 2007?
Ensure brevity in your answer.  1. What is the ratio of the Total Labor Force (in %) in Canada in 2006 to that in 2007?
Keep it short and to the point. 0.99. What is the ratio of the Total Labor Force (in %) of Lao PDR in 2006 to that in 2007?
Offer a very short reply. 1. What is the ratio of the Total Labor Force (in %) of Lao PDR in 2006 to that in 2008?
Offer a very short reply. 1.01. What is the ratio of the Total Labor Force (in %) in Macedonia in 2006 to that in 2008?
Provide a short and direct response. 0.98. What is the ratio of the Total Labor Force (in %) in Lao PDR in 2006 to that in 2009?
Make the answer very short. 1.01. What is the ratio of the Total Labor Force (in %) in Macedonia in 2006 to that in 2009?
Give a very brief answer. 0.98. What is the ratio of the Total Labor Force (in %) in Middle East & North Africa (all income levels) in 2006 to that in 2010?
Make the answer very short. 0.99. What is the ratio of the Total Labor Force (in %) of Canada in 2006 to that in 2010?
Give a very brief answer. 1. What is the ratio of the Total Labor Force (in %) of Lao PDR in 2006 to that in 2010?
Ensure brevity in your answer.  1.01. What is the ratio of the Total Labor Force (in %) of Middle East & North Africa (all income levels) in 2006 to that in 2011?
Give a very brief answer. 0.99. What is the ratio of the Total Labor Force (in %) in Canada in 2006 to that in 2011?
Ensure brevity in your answer.  1. What is the ratio of the Total Labor Force (in %) of Macedonia in 2006 to that in 2011?
Keep it short and to the point. 0.98. What is the ratio of the Total Labor Force (in %) in Middle East & North Africa (all income levels) in 2006 to that in 2012?
Keep it short and to the point. 0.98. What is the ratio of the Total Labor Force (in %) of Canada in 2006 to that in 2012?
Your answer should be compact. 1. What is the ratio of the Total Labor Force (in %) in Lao PDR in 2006 to that in 2012?
Your answer should be very brief. 1.01. What is the ratio of the Total Labor Force (in %) in Macedonia in 2006 to that in 2012?
Provide a succinct answer. 0.98. What is the ratio of the Total Labor Force (in %) in Middle East & North Africa (all income levels) in 2007 to that in 2008?
Provide a succinct answer. 1.01. What is the ratio of the Total Labor Force (in %) of Lao PDR in 2007 to that in 2008?
Keep it short and to the point. 1. What is the ratio of the Total Labor Force (in %) of Canada in 2007 to that in 2009?
Give a very brief answer. 1. What is the ratio of the Total Labor Force (in %) of Macedonia in 2007 to that in 2009?
Offer a terse response. 0.98. What is the ratio of the Total Labor Force (in %) in Canada in 2007 to that in 2010?
Your answer should be compact. 1.01. What is the ratio of the Total Labor Force (in %) in Macedonia in 2007 to that in 2010?
Offer a very short reply. 0.98. What is the ratio of the Total Labor Force (in %) of Middle East & North Africa (all income levels) in 2007 to that in 2011?
Ensure brevity in your answer.  0.99. What is the ratio of the Total Labor Force (in %) in Canada in 2007 to that in 2011?
Your response must be concise. 1.01. What is the ratio of the Total Labor Force (in %) of Lao PDR in 2007 to that in 2011?
Your answer should be compact. 1.01. What is the ratio of the Total Labor Force (in %) in Macedonia in 2007 to that in 2011?
Offer a very short reply. 0.98. What is the ratio of the Total Labor Force (in %) of Middle East & North Africa (all income levels) in 2007 to that in 2012?
Offer a very short reply. 0.98. What is the ratio of the Total Labor Force (in %) in Canada in 2007 to that in 2012?
Provide a succinct answer. 1.01. What is the ratio of the Total Labor Force (in %) in Lao PDR in 2007 to that in 2012?
Ensure brevity in your answer.  1.01. What is the ratio of the Total Labor Force (in %) in Middle East & North Africa (all income levels) in 2008 to that in 2009?
Ensure brevity in your answer.  1. What is the ratio of the Total Labor Force (in %) of Canada in 2008 to that in 2009?
Ensure brevity in your answer.  1.01. What is the ratio of the Total Labor Force (in %) in Macedonia in 2008 to that in 2009?
Offer a terse response. 0.99. What is the ratio of the Total Labor Force (in %) in Middle East & North Africa (all income levels) in 2008 to that in 2010?
Offer a very short reply. 0.99. What is the ratio of the Total Labor Force (in %) of Canada in 2008 to that in 2010?
Keep it short and to the point. 1.01. What is the ratio of the Total Labor Force (in %) of Middle East & North Africa (all income levels) in 2008 to that in 2011?
Provide a succinct answer. 0.98. What is the ratio of the Total Labor Force (in %) in Canada in 2008 to that in 2011?
Offer a terse response. 1.01. What is the ratio of the Total Labor Force (in %) of Macedonia in 2008 to that in 2011?
Your answer should be very brief. 0.99. What is the ratio of the Total Labor Force (in %) of Middle East & North Africa (all income levels) in 2008 to that in 2012?
Give a very brief answer. 0.98. What is the ratio of the Total Labor Force (in %) in Canada in 2008 to that in 2012?
Make the answer very short. 1.02. What is the ratio of the Total Labor Force (in %) in Lao PDR in 2008 to that in 2012?
Ensure brevity in your answer.  1. What is the ratio of the Total Labor Force (in %) in Middle East & North Africa (all income levels) in 2009 to that in 2010?
Your response must be concise. 0.99. What is the ratio of the Total Labor Force (in %) in Canada in 2009 to that in 2010?
Ensure brevity in your answer.  1. What is the ratio of the Total Labor Force (in %) in Macedonia in 2009 to that in 2010?
Your response must be concise. 1. What is the ratio of the Total Labor Force (in %) in Middle East & North Africa (all income levels) in 2009 to that in 2011?
Offer a terse response. 0.99. What is the ratio of the Total Labor Force (in %) of Canada in 2009 to that in 2011?
Ensure brevity in your answer.  1.01. What is the ratio of the Total Labor Force (in %) of Lao PDR in 2009 to that in 2011?
Keep it short and to the point. 1. What is the ratio of the Total Labor Force (in %) in Middle East & North Africa (all income levels) in 2009 to that in 2012?
Provide a succinct answer. 0.98. What is the ratio of the Total Labor Force (in %) in Canada in 2009 to that in 2012?
Offer a very short reply. 1.01. What is the ratio of the Total Labor Force (in %) in Macedonia in 2009 to that in 2012?
Offer a terse response. 1.01. What is the ratio of the Total Labor Force (in %) in Middle East & North Africa (all income levels) in 2010 to that in 2011?
Provide a short and direct response. 0.99. What is the ratio of the Total Labor Force (in %) in Macedonia in 2010 to that in 2011?
Provide a succinct answer. 1. What is the ratio of the Total Labor Force (in %) of Middle East & North Africa (all income levels) in 2010 to that in 2012?
Offer a terse response. 0.99. What is the ratio of the Total Labor Force (in %) of Macedonia in 2010 to that in 2012?
Your response must be concise. 1.01. What is the ratio of the Total Labor Force (in %) in Lao PDR in 2011 to that in 2012?
Give a very brief answer. 1. What is the ratio of the Total Labor Force (in %) of Macedonia in 2011 to that in 2012?
Keep it short and to the point. 1.01. What is the difference between the highest and the second highest Total Labor Force (in %) in Middle East & North Africa (all income levels)?
Give a very brief answer. 0.4. What is the difference between the highest and the second highest Total Labor Force (in %) in Macedonia?
Ensure brevity in your answer.  0.2. What is the difference between the highest and the lowest Total Labor Force (in %) of Middle East & North Africa (all income levels)?
Keep it short and to the point. 1.18. What is the difference between the highest and the lowest Total Labor Force (in %) in Lao PDR?
Your answer should be compact. 1. What is the difference between the highest and the lowest Total Labor Force (in %) of Macedonia?
Provide a succinct answer. 2.6. 